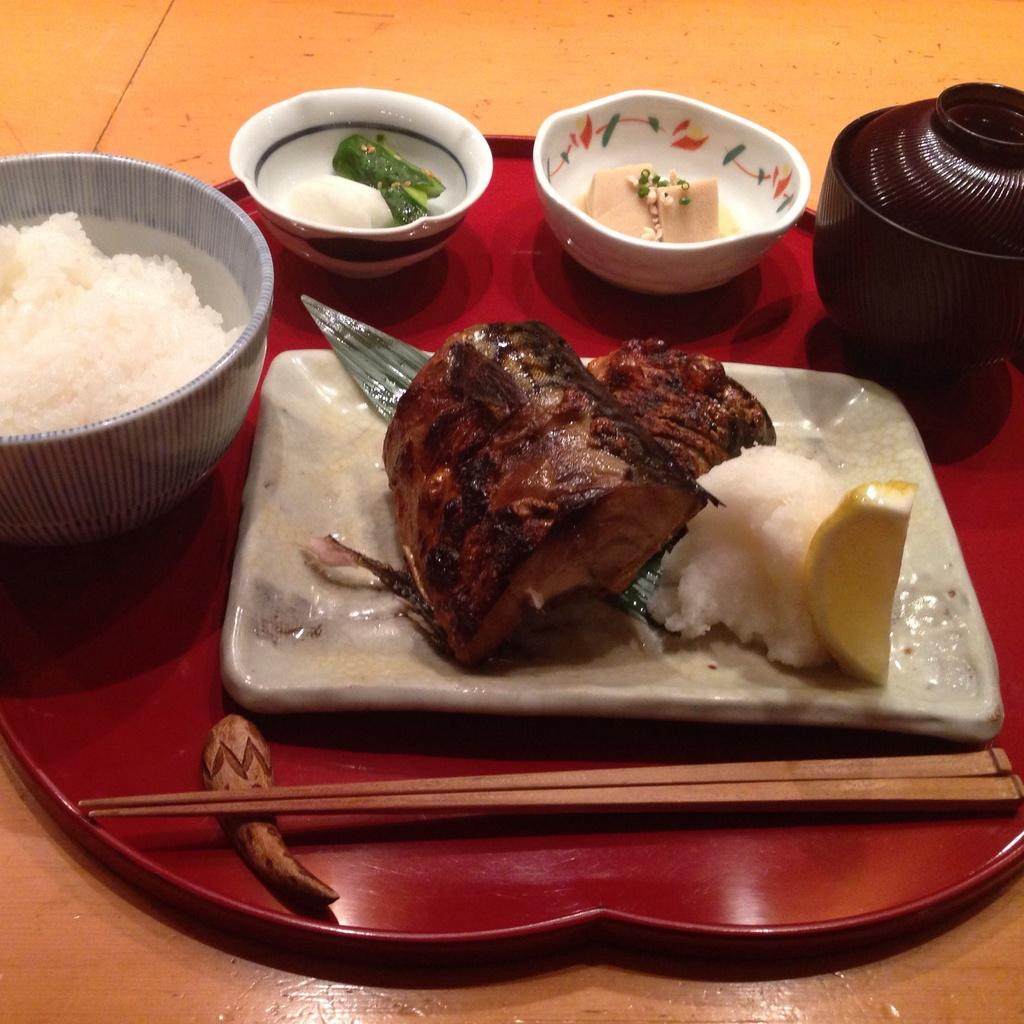What is on the plate that is visible in the image? There is a plate with food in the image. What else is on the red color board besides the plate? There are bowls with food and chopsticks visible in the image. What color is the board that the plate, bowls, and chopsticks are on? The board is red color. What is the surface beneath the red color board? The red color board is on a brown color surface. What type of animal is on the committee in the image? There is no committee or animal present in the image. 